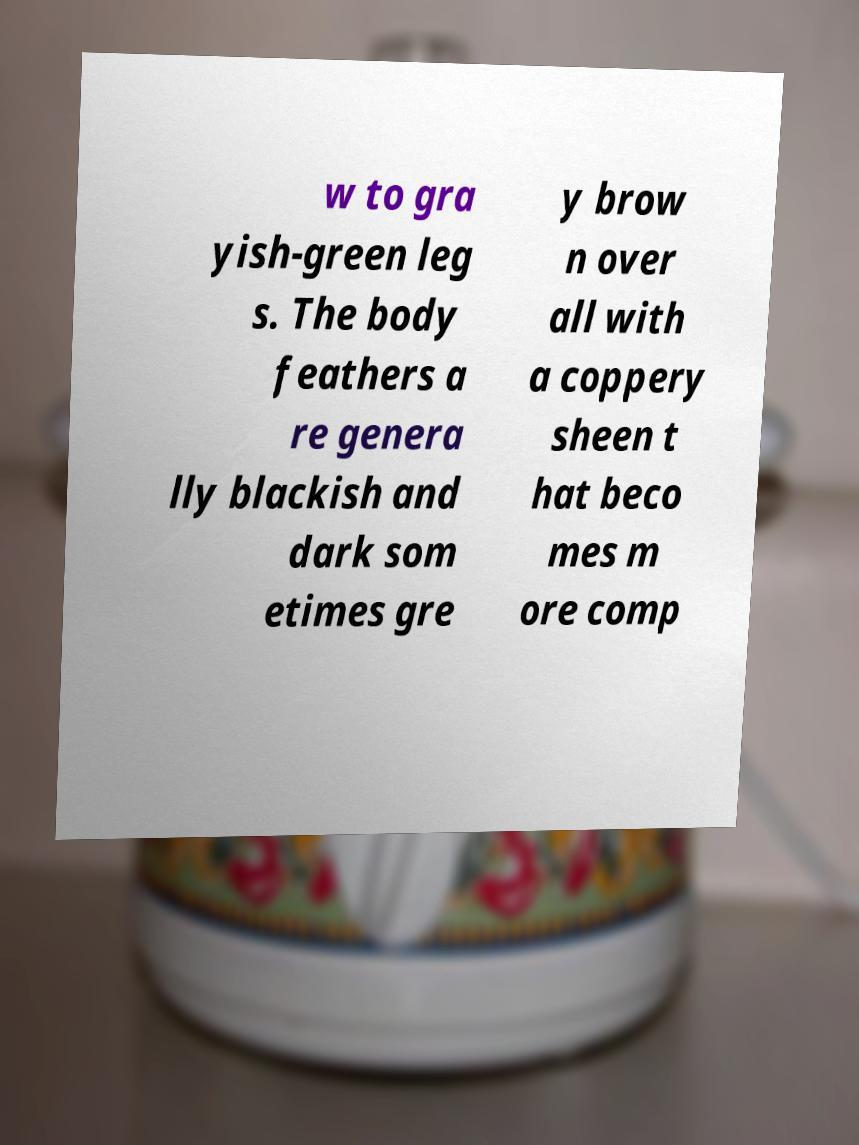I need the written content from this picture converted into text. Can you do that? w to gra yish-green leg s. The body feathers a re genera lly blackish and dark som etimes gre y brow n over all with a coppery sheen t hat beco mes m ore comp 